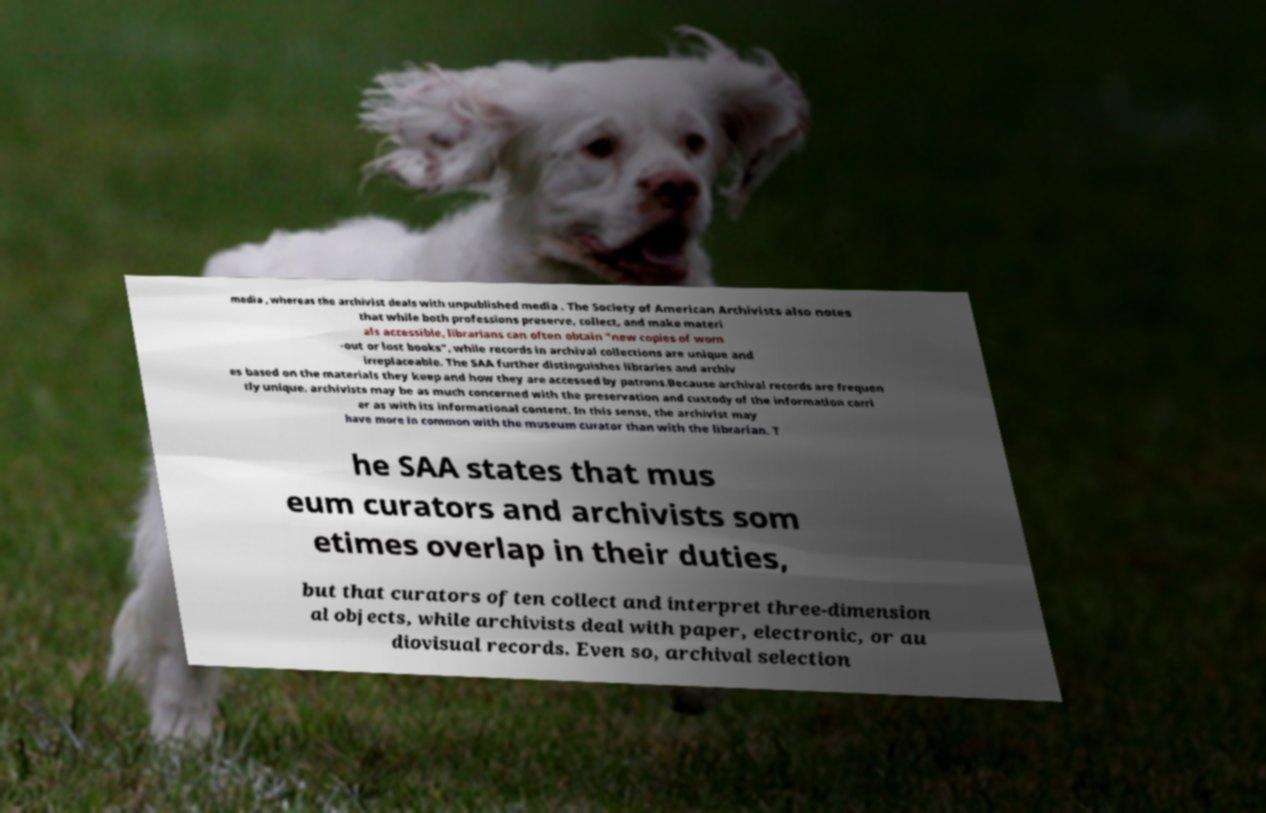Can you read and provide the text displayed in the image?This photo seems to have some interesting text. Can you extract and type it out for me? media , whereas the archivist deals with unpublished media . The Society of American Archivists also notes that while both professions preserve, collect, and make materi als accessible, librarians can often obtain "new copies of worn -out or lost books", while records in archival collections are unique and irreplaceable. The SAA further distinguishes libraries and archiv es based on the materials they keep and how they are accessed by patrons.Because archival records are frequen tly unique, archivists may be as much concerned with the preservation and custody of the information carri er as with its informational content. In this sense, the archivist may have more in common with the museum curator than with the librarian. T he SAA states that mus eum curators and archivists som etimes overlap in their duties, but that curators often collect and interpret three-dimension al objects, while archivists deal with paper, electronic, or au diovisual records. Even so, archival selection 